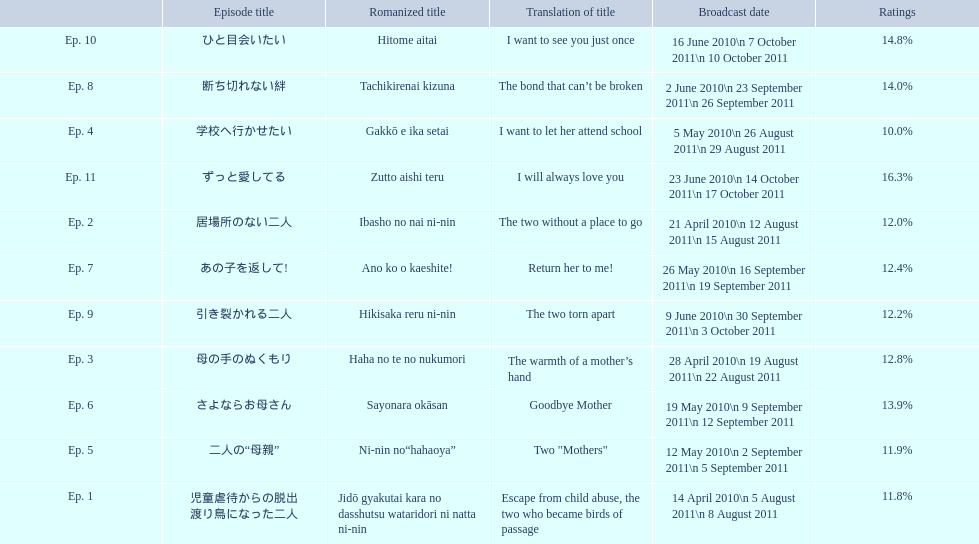What are the episodes of mother? 児童虐待からの脱出 渡り鳥になった二人, 居場所のない二人, 母の手のぬくもり, 学校へ行かせたい, 二人の“母親”, さよならお母さん, あの子を返して!, 断ち切れない絆, 引き裂かれる二人, ひと目会いたい, ずっと愛してる. What is the rating of episode 10? 14.8%. What is the other rating also in the 14 to 15 range? Ep. 8. 